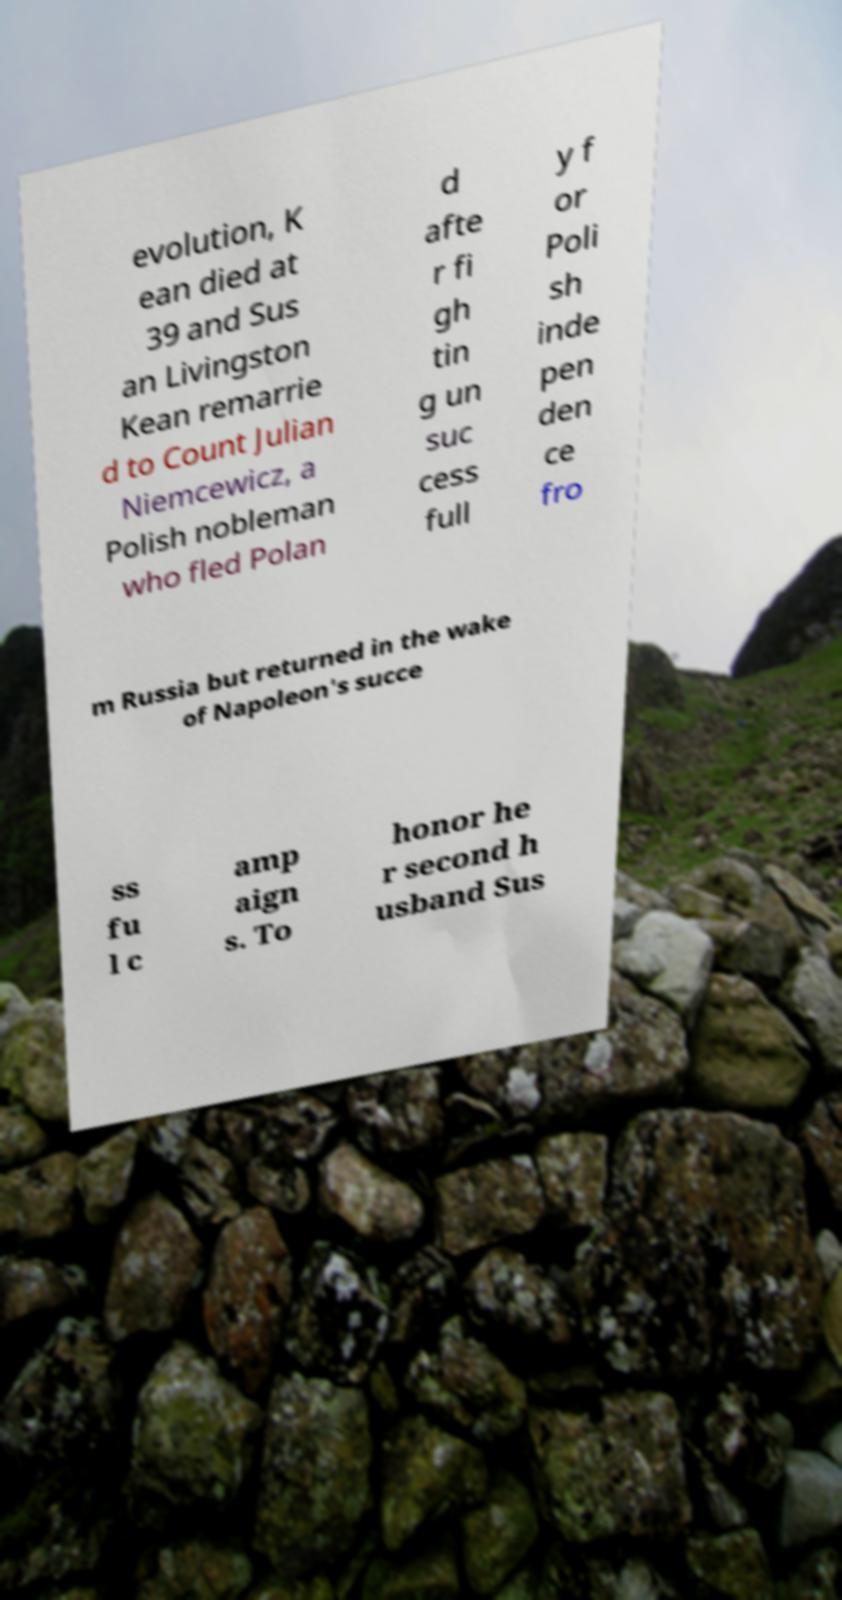There's text embedded in this image that I need extracted. Can you transcribe it verbatim? evolution, K ean died at 39 and Sus an Livingston Kean remarrie d to Count Julian Niemcewicz, a Polish nobleman who fled Polan d afte r fi gh tin g un suc cess full y f or Poli sh inde pen den ce fro m Russia but returned in the wake of Napoleon's succe ss fu l c amp aign s. To honor he r second h usband Sus 